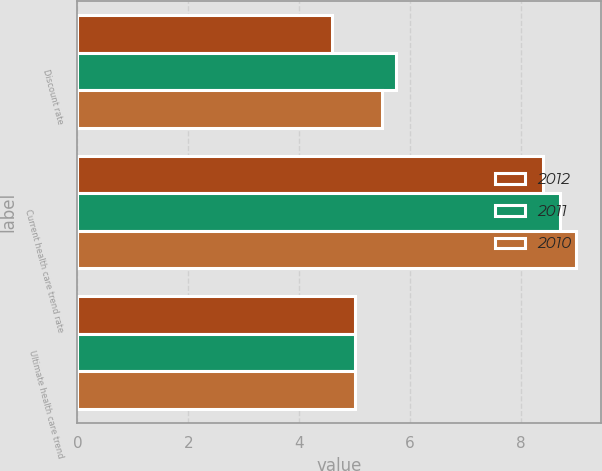Convert chart to OTSL. <chart><loc_0><loc_0><loc_500><loc_500><stacked_bar_chart><ecel><fcel>Discount rate<fcel>Current health care trend rate<fcel>Ultimate health care trend<nl><fcel>2012<fcel>4.6<fcel>8.4<fcel>5<nl><fcel>2011<fcel>5.75<fcel>8.7<fcel>5<nl><fcel>2010<fcel>5.5<fcel>9<fcel>5<nl></chart> 